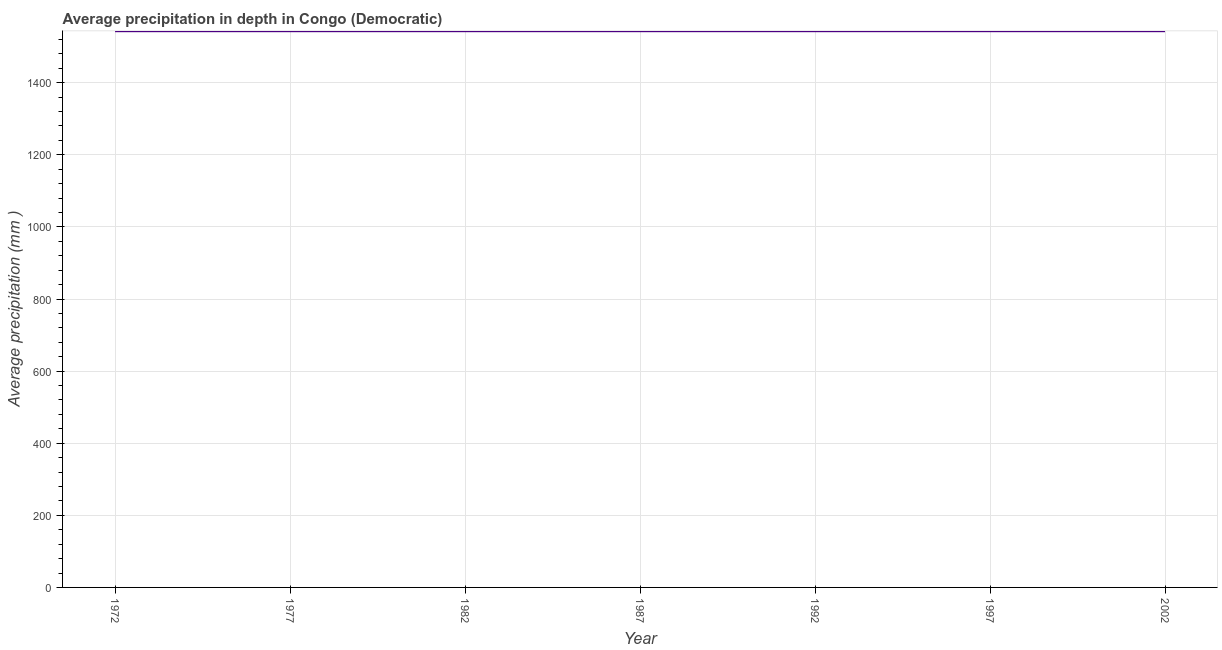What is the average precipitation in depth in 1987?
Ensure brevity in your answer.  1543. Across all years, what is the maximum average precipitation in depth?
Ensure brevity in your answer.  1543. Across all years, what is the minimum average precipitation in depth?
Offer a terse response. 1543. In which year was the average precipitation in depth maximum?
Keep it short and to the point. 1972. What is the sum of the average precipitation in depth?
Keep it short and to the point. 1.08e+04. What is the difference between the average precipitation in depth in 1972 and 1992?
Offer a very short reply. 0. What is the average average precipitation in depth per year?
Keep it short and to the point. 1543. What is the median average precipitation in depth?
Provide a short and direct response. 1543. In how many years, is the average precipitation in depth greater than 240 mm?
Provide a short and direct response. 7. What is the difference between the highest and the lowest average precipitation in depth?
Your response must be concise. 0. Does the average precipitation in depth monotonically increase over the years?
Ensure brevity in your answer.  No. How many lines are there?
Ensure brevity in your answer.  1. How many years are there in the graph?
Your response must be concise. 7. What is the difference between two consecutive major ticks on the Y-axis?
Offer a very short reply. 200. Are the values on the major ticks of Y-axis written in scientific E-notation?
Your response must be concise. No. Does the graph contain grids?
Make the answer very short. Yes. What is the title of the graph?
Keep it short and to the point. Average precipitation in depth in Congo (Democratic). What is the label or title of the X-axis?
Offer a very short reply. Year. What is the label or title of the Y-axis?
Ensure brevity in your answer.  Average precipitation (mm ). What is the Average precipitation (mm ) of 1972?
Make the answer very short. 1543. What is the Average precipitation (mm ) in 1977?
Provide a succinct answer. 1543. What is the Average precipitation (mm ) in 1982?
Provide a succinct answer. 1543. What is the Average precipitation (mm ) of 1987?
Make the answer very short. 1543. What is the Average precipitation (mm ) in 1992?
Offer a terse response. 1543. What is the Average precipitation (mm ) in 1997?
Your answer should be very brief. 1543. What is the Average precipitation (mm ) in 2002?
Ensure brevity in your answer.  1543. What is the difference between the Average precipitation (mm ) in 1972 and 1982?
Make the answer very short. 0. What is the difference between the Average precipitation (mm ) in 1972 and 1987?
Keep it short and to the point. 0. What is the difference between the Average precipitation (mm ) in 1972 and 1992?
Make the answer very short. 0. What is the difference between the Average precipitation (mm ) in 1972 and 1997?
Provide a succinct answer. 0. What is the difference between the Average precipitation (mm ) in 1977 and 1987?
Offer a very short reply. 0. What is the difference between the Average precipitation (mm ) in 1977 and 1992?
Your response must be concise. 0. What is the difference between the Average precipitation (mm ) in 1977 and 1997?
Your answer should be compact. 0. What is the difference between the Average precipitation (mm ) in 1982 and 1992?
Offer a terse response. 0. What is the ratio of the Average precipitation (mm ) in 1972 to that in 1977?
Offer a terse response. 1. What is the ratio of the Average precipitation (mm ) in 1972 to that in 2002?
Provide a short and direct response. 1. What is the ratio of the Average precipitation (mm ) in 1977 to that in 1992?
Your answer should be very brief. 1. What is the ratio of the Average precipitation (mm ) in 1982 to that in 1987?
Keep it short and to the point. 1. What is the ratio of the Average precipitation (mm ) in 1982 to that in 1992?
Your answer should be very brief. 1. What is the ratio of the Average precipitation (mm ) in 1982 to that in 1997?
Offer a terse response. 1. What is the ratio of the Average precipitation (mm ) in 1987 to that in 1992?
Provide a short and direct response. 1. What is the ratio of the Average precipitation (mm ) in 1992 to that in 1997?
Ensure brevity in your answer.  1. 